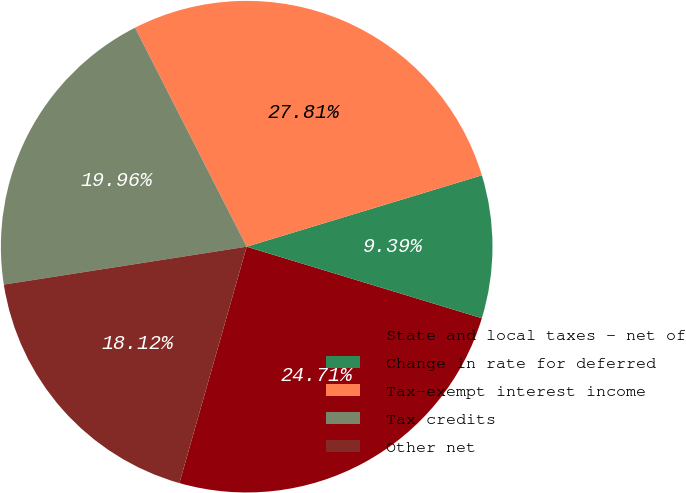Convert chart. <chart><loc_0><loc_0><loc_500><loc_500><pie_chart><fcel>State and local taxes - net of<fcel>Change in rate for deferred<fcel>Tax-exempt interest income<fcel>Tax credits<fcel>Other net<nl><fcel>24.71%<fcel>9.39%<fcel>27.81%<fcel>19.96%<fcel>18.12%<nl></chart> 